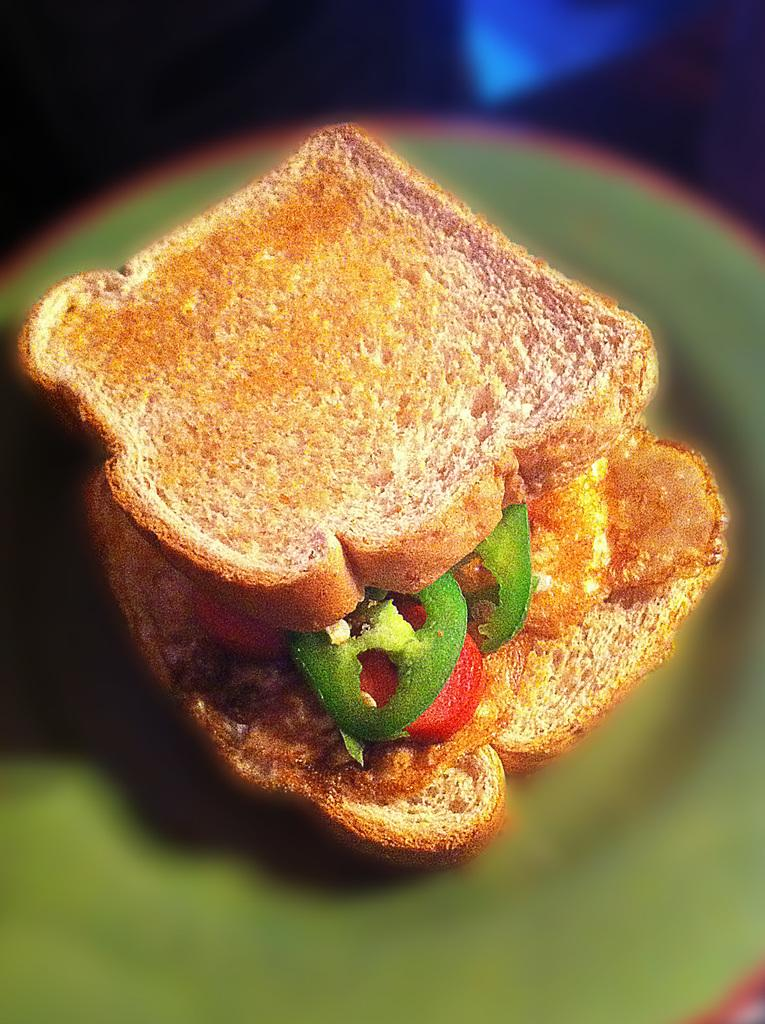What type of food is visible in the image? There are slices of green pepper in the image. How are the green pepper slices arranged? The green pepper slices are stuffed in between toasted bread. Where are the toasted bread and green pepper slices located? They are placed on a table. What type of rose is being distributed in the image? There is no rose or distribution present in the image; it features green pepper slices stuffed in between toasted bread on a table. 